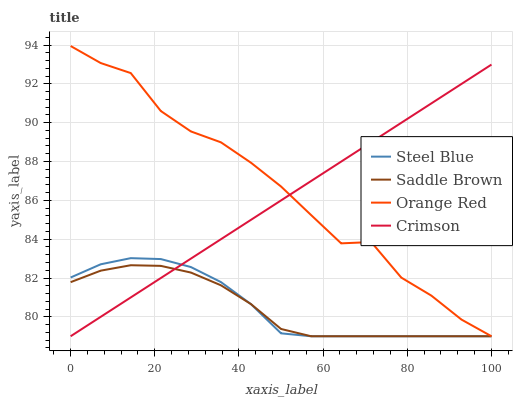Does Saddle Brown have the minimum area under the curve?
Answer yes or no. Yes. Does Orange Red have the maximum area under the curve?
Answer yes or no. Yes. Does Steel Blue have the minimum area under the curve?
Answer yes or no. No. Does Steel Blue have the maximum area under the curve?
Answer yes or no. No. Is Crimson the smoothest?
Answer yes or no. Yes. Is Orange Red the roughest?
Answer yes or no. Yes. Is Steel Blue the smoothest?
Answer yes or no. No. Is Steel Blue the roughest?
Answer yes or no. No. Does Orange Red have the highest value?
Answer yes or no. Yes. Does Steel Blue have the highest value?
Answer yes or no. No. Does Saddle Brown intersect Steel Blue?
Answer yes or no. Yes. Is Saddle Brown less than Steel Blue?
Answer yes or no. No. Is Saddle Brown greater than Steel Blue?
Answer yes or no. No. 